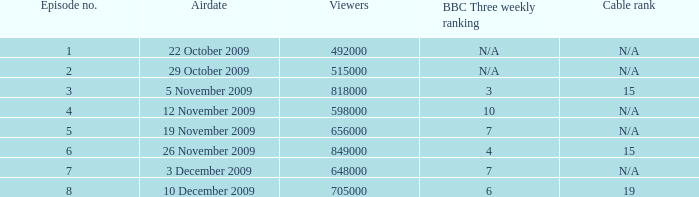How many entries are exhibited for viewers when the airdate was 26 november 2009? 1.0. Give me the full table as a dictionary. {'header': ['Episode no.', 'Airdate', 'Viewers', 'BBC Three weekly ranking', 'Cable rank'], 'rows': [['1', '22 October 2009', '492000', 'N/A', 'N/A'], ['2', '29 October 2009', '515000', 'N/A', 'N/A'], ['3', '5 November 2009', '818000', '3', '15'], ['4', '12 November 2009', '598000', '10', 'N/A'], ['5', '19 November 2009', '656000', '7', 'N/A'], ['6', '26 November 2009', '849000', '4', '15'], ['7', '3 December 2009', '648000', '7', 'N/A'], ['8', '10 December 2009', '705000', '6', '19']]} 